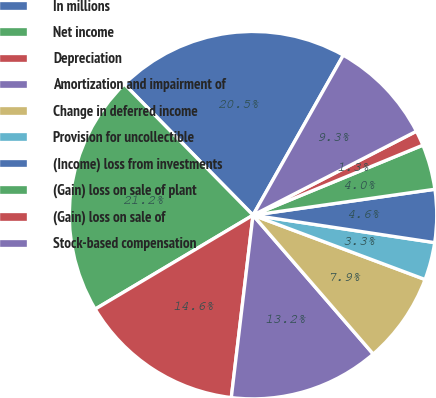Convert chart. <chart><loc_0><loc_0><loc_500><loc_500><pie_chart><fcel>In millions<fcel>Net income<fcel>Depreciation<fcel>Amortization and impairment of<fcel>Change in deferred income<fcel>Provision for uncollectible<fcel>(Income) loss from investments<fcel>(Gain) loss on sale of plant<fcel>(Gain) loss on sale of<fcel>Stock-based compensation<nl><fcel>20.53%<fcel>21.19%<fcel>14.57%<fcel>13.24%<fcel>7.95%<fcel>3.31%<fcel>4.64%<fcel>3.97%<fcel>1.33%<fcel>9.27%<nl></chart> 